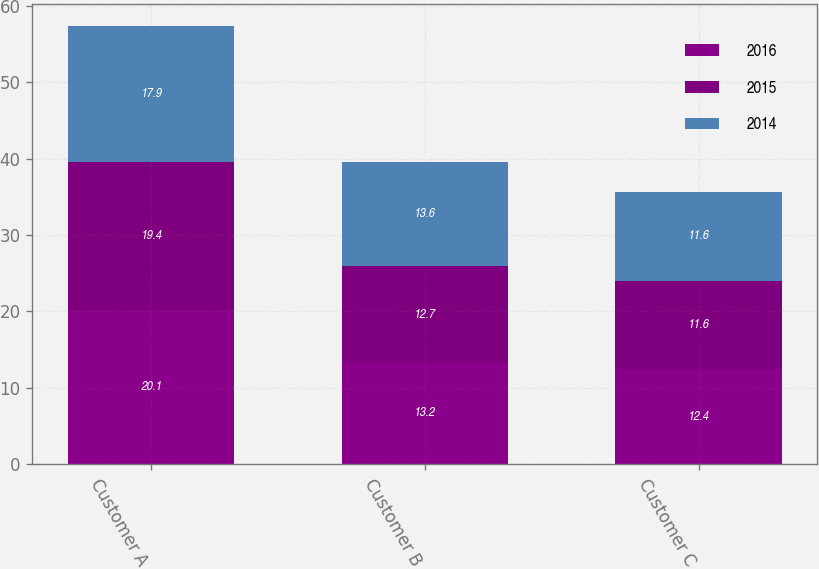Convert chart to OTSL. <chart><loc_0><loc_0><loc_500><loc_500><stacked_bar_chart><ecel><fcel>Customer A<fcel>Customer B<fcel>Customer C<nl><fcel>2016<fcel>20.1<fcel>13.2<fcel>12.4<nl><fcel>2015<fcel>19.4<fcel>12.7<fcel>11.6<nl><fcel>2014<fcel>17.9<fcel>13.6<fcel>11.6<nl></chart> 